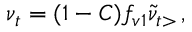Convert formula to latex. <formula><loc_0><loc_0><loc_500><loc_500>\nu _ { t } = ( 1 - C ) f _ { v 1 } \tilde { \nu } _ { t > } \, ,</formula> 